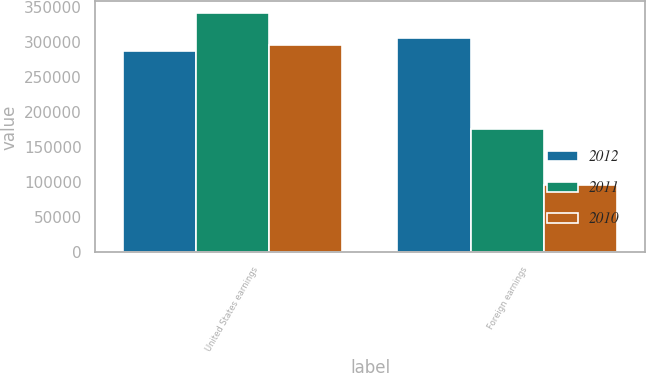Convert chart. <chart><loc_0><loc_0><loc_500><loc_500><stacked_bar_chart><ecel><fcel>United States earnings<fcel>Foreign earnings<nl><fcel>2012<fcel>286987<fcel>306349<nl><fcel>2011<fcel>341059<fcel>175602<nl><fcel>2010<fcel>295144<fcel>96790<nl></chart> 